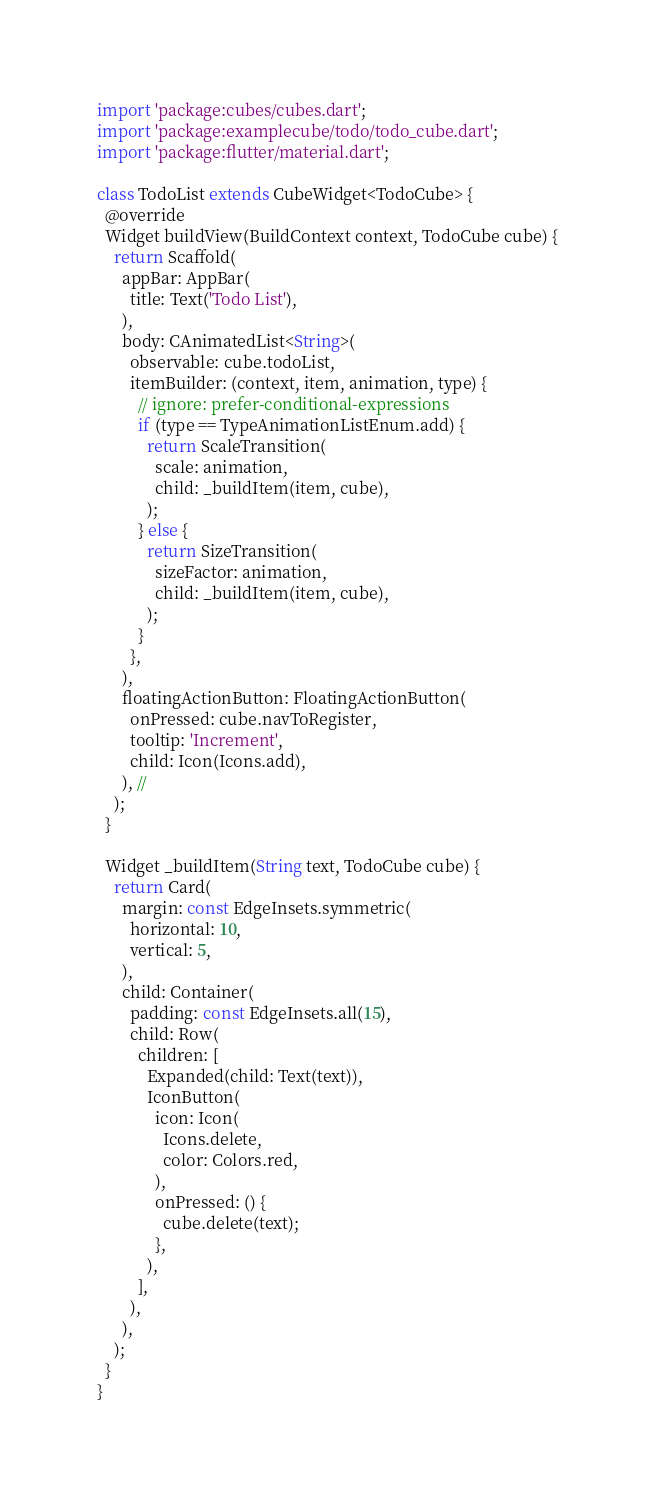Convert code to text. <code><loc_0><loc_0><loc_500><loc_500><_Dart_>import 'package:cubes/cubes.dart';
import 'package:examplecube/todo/todo_cube.dart';
import 'package:flutter/material.dart';

class TodoList extends CubeWidget<TodoCube> {
  @override
  Widget buildView(BuildContext context, TodoCube cube) {
    return Scaffold(
      appBar: AppBar(
        title: Text('Todo List'),
      ),
      body: CAnimatedList<String>(
        observable: cube.todoList,
        itemBuilder: (context, item, animation, type) {
          // ignore: prefer-conditional-expressions
          if (type == TypeAnimationListEnum.add) {
            return ScaleTransition(
              scale: animation,
              child: _buildItem(item, cube),
            );
          } else {
            return SizeTransition(
              sizeFactor: animation,
              child: _buildItem(item, cube),
            );
          }
        },
      ),
      floatingActionButton: FloatingActionButton(
        onPressed: cube.navToRegister,
        tooltip: 'Increment',
        child: Icon(Icons.add),
      ), //
    );
  }

  Widget _buildItem(String text, TodoCube cube) {
    return Card(
      margin: const EdgeInsets.symmetric(
        horizontal: 10,
        vertical: 5,
      ),
      child: Container(
        padding: const EdgeInsets.all(15),
        child: Row(
          children: [
            Expanded(child: Text(text)),
            IconButton(
              icon: Icon(
                Icons.delete,
                color: Colors.red,
              ),
              onPressed: () {
                cube.delete(text);
              },
            ),
          ],
        ),
      ),
    );
  }
}
</code> 